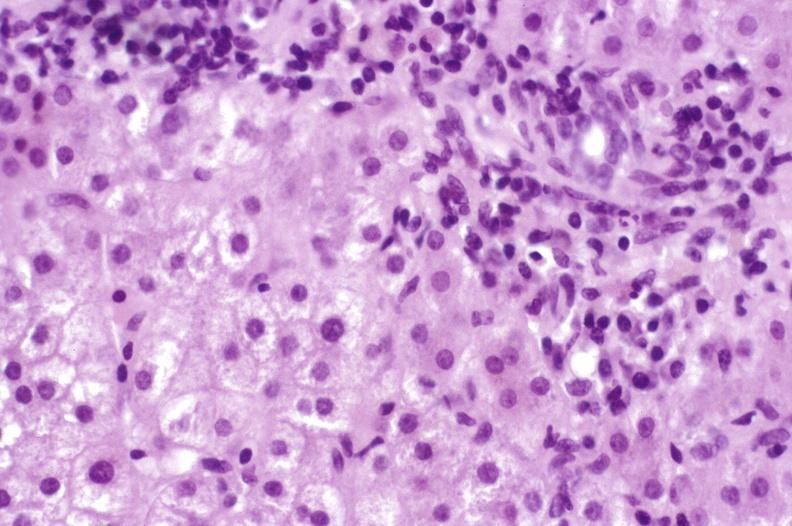s hemorrhage associated with placental abruption present?
Answer the question using a single word or phrase. No 